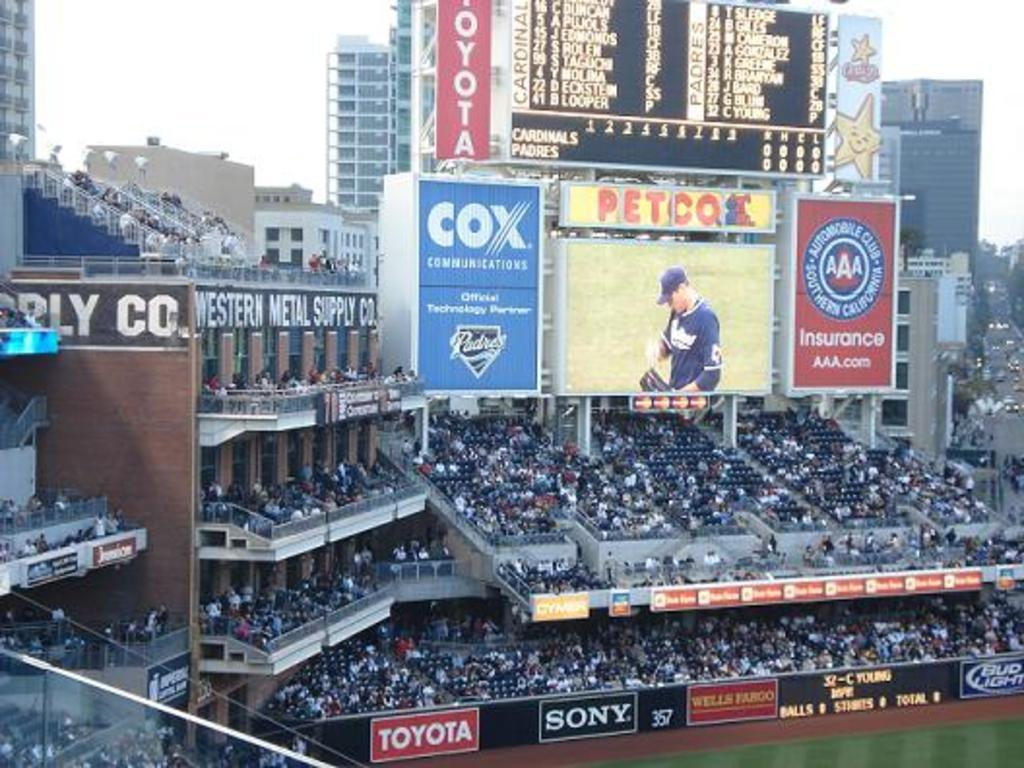<image>
Provide a brief description of the given image. A portion of the petco sadium with adverts for cox and other brands. 